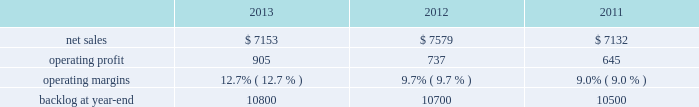Mfc 2019s operating profit for 2013 increased $ 175 million , or 14% ( 14 % ) , compared to 2012 .
The increase was primarily attributable to higher operating profit of approximately $ 85 million for air and missile defense programs ( thaad and pac-3 ) due to increased risk retirements and volume ; about $ 85 million for fire control programs ( sniper ae , lantirn ae and apache ) due to increased risk retirements and higher volume ; and approximately $ 75 million for tactical missile programs ( hellfire and various programs ) due to increased risk retirements .
The increases were partially offset by lower operating profit of about $ 45 million for the resolution of contractual matters in the second quarter of 2012 ; and approximately $ 15 million for various technical services programs due to lower volume partially offset by increased risk retirements .
Adjustments not related to volume , including net profit booking rate adjustments and other matters , were approximately $ 100 million higher for 2013 compared to 2012 .
2012 compared to 2011 mfc 2019s net sales for 2012 were comparable to 2011 .
Net sales decreased approximately $ 130 million due to lower volume and risk retirements on various services programs , and about $ 60 million due to lower volume from fire control systems programs ( primarily sniper ae ; lantirn ae ; and apache ) .
The decreases largely were offset by higher net sales of approximately $ 95 million due to higher volume from tactical missile programs ( primarily javelin and hellfire ) and approximately $ 80 million for air and missile defense programs ( primarily pac-3 and thaad ) .
Mfc 2019s operating profit for 2012 increased $ 187 million , or 17% ( 17 % ) , compared to 2011 .
The increase was attributable to higher risk retirements and volume of about $ 95 million from tactical missile programs ( primarily javelin and hellfire ) ; increased risk retirements and volume of approximately $ 60 million for air and missile defense programs ( primarily thaad and pac-3 ) ; and about $ 45 million from a resolution of contractual matters .
Partially offsetting these increases was lower risk retirements and volume on various programs , including $ 25 million for services programs .
Adjustments not related to volume , including net profit booking rate adjustments and other matters described above , were approximately $ 145 million higher for 2012 compared to 2011 .
Backlog backlog increased in 2013 compared to 2012 mainly due to higher orders on the thaad program and lower sales volume compared to new orders on certain fire control systems programs in 2013 , partially offset by lower orders on technical services programs and certain tactical missile programs .
Backlog increased in 2012 compared to 2011 mainly due to increased orders and lower sales on fire control systems programs ( primarily lantirn ae and sniper ae ) and on various services programs , partially offset by lower orders and higher sales volume on tactical missiles programs .
Trends we expect mfc 2019s net sales to be flat to slightly down in 2014 compared to 2013 , primarily due to a decrease in net sales on technical services programs partially offset by an increase in net sales from missiles and fire control programs .
Operating profit is expected to decrease in the high single digit percentage range , driven by a reduction in expected risk retirements in 2014 .
Accordingly , operating profit margin is expected to slightly decline from 2013 .
Mission systems and training our mst business segment provides ship and submarine mission and combat systems ; mission systems and sensors for rotary and fixed-wing aircraft ; sea and land-based missile defense systems ; radar systems ; littoral combat ships ; simulation and training services ; and unmanned systems and technologies .
Mst 2019s major programs include aegis combat system ( aegis ) , lcs , mh-60 , tpq-53 radar system , and mk-41 vertical launching system ( vls ) .
Mst 2019s operating results included the following ( in millions ) : .
2013 compared to 2012 mst 2019s net sales for 2013 decreased $ 426 million , or 6% ( 6 % ) , compared to 2012 .
The decrease was primarily attributable to lower net sales of approximately $ 275 million for various ship and aviation systems programs due to lower volume .
What were average net sales from 2011 to 2013 for mst in millions? 
Computations: table_average(net sales, none)
Answer: 7288.0. 